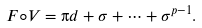<formula> <loc_0><loc_0><loc_500><loc_500>F \circ V = \i d + \sigma + \dots + \sigma ^ { p - 1 } .</formula> 